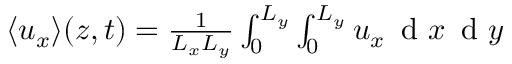Convert formula to latex. <formula><loc_0><loc_0><loc_500><loc_500>\begin{array} { r } { \langle u _ { x } \rangle ( z , t ) = \frac { 1 } { L _ { x } L _ { y } } \int _ { 0 } ^ { L _ { y } } \int _ { 0 } ^ { L _ { y } } u _ { x } \, d x \, d y } \end{array}</formula> 